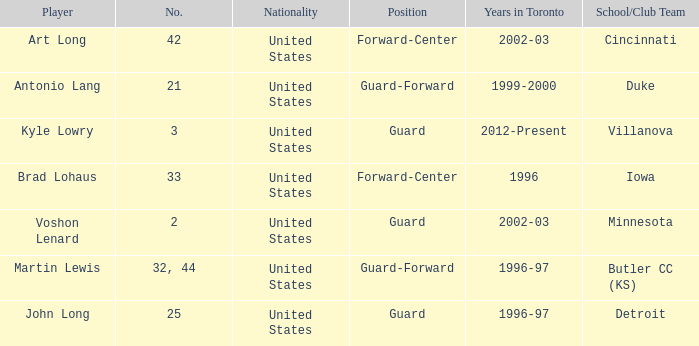What school did player number 21 play for? Duke. 